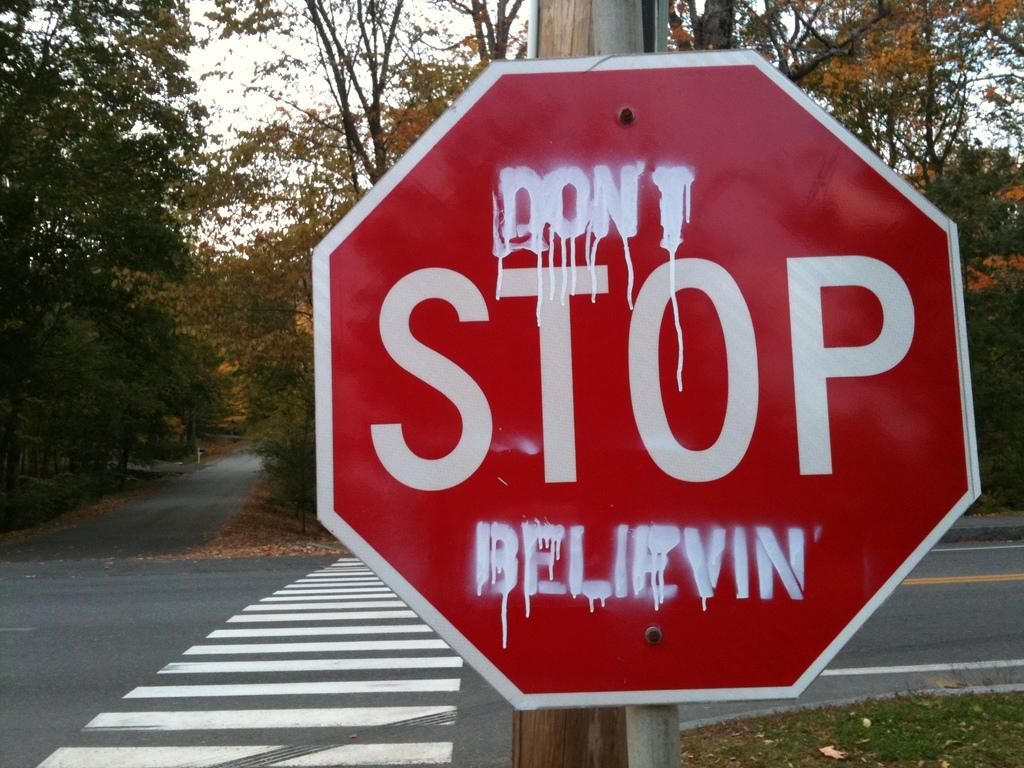<image>
Give a short and clear explanation of the subsequent image. A STOP sign has been illegally altered to read DON'T STOP BELIEVIN. 